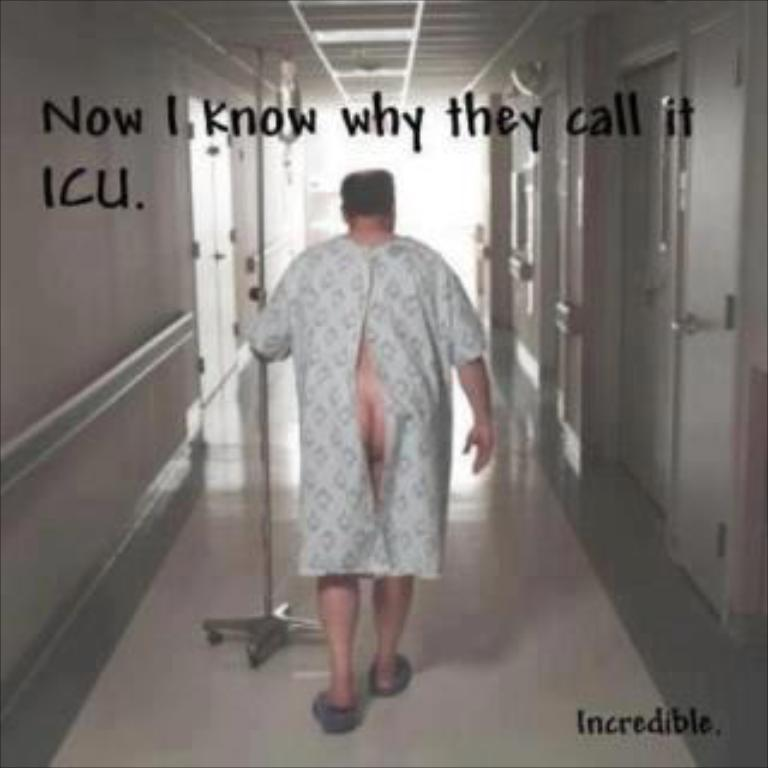Who is present in the image? There is a person in the image. What is the person wearing? The person is wearing a white dress. What is the person doing in the image? The person is walking through the floor. What is the person holding in their hands? The person is holding a stick in their hands. What can be seen on the sides of the image? There are doors on the left side and the right side of the image. What year is the meeting taking place in the image? There is no meeting present in the image, and therefore no specific year can be determined. 